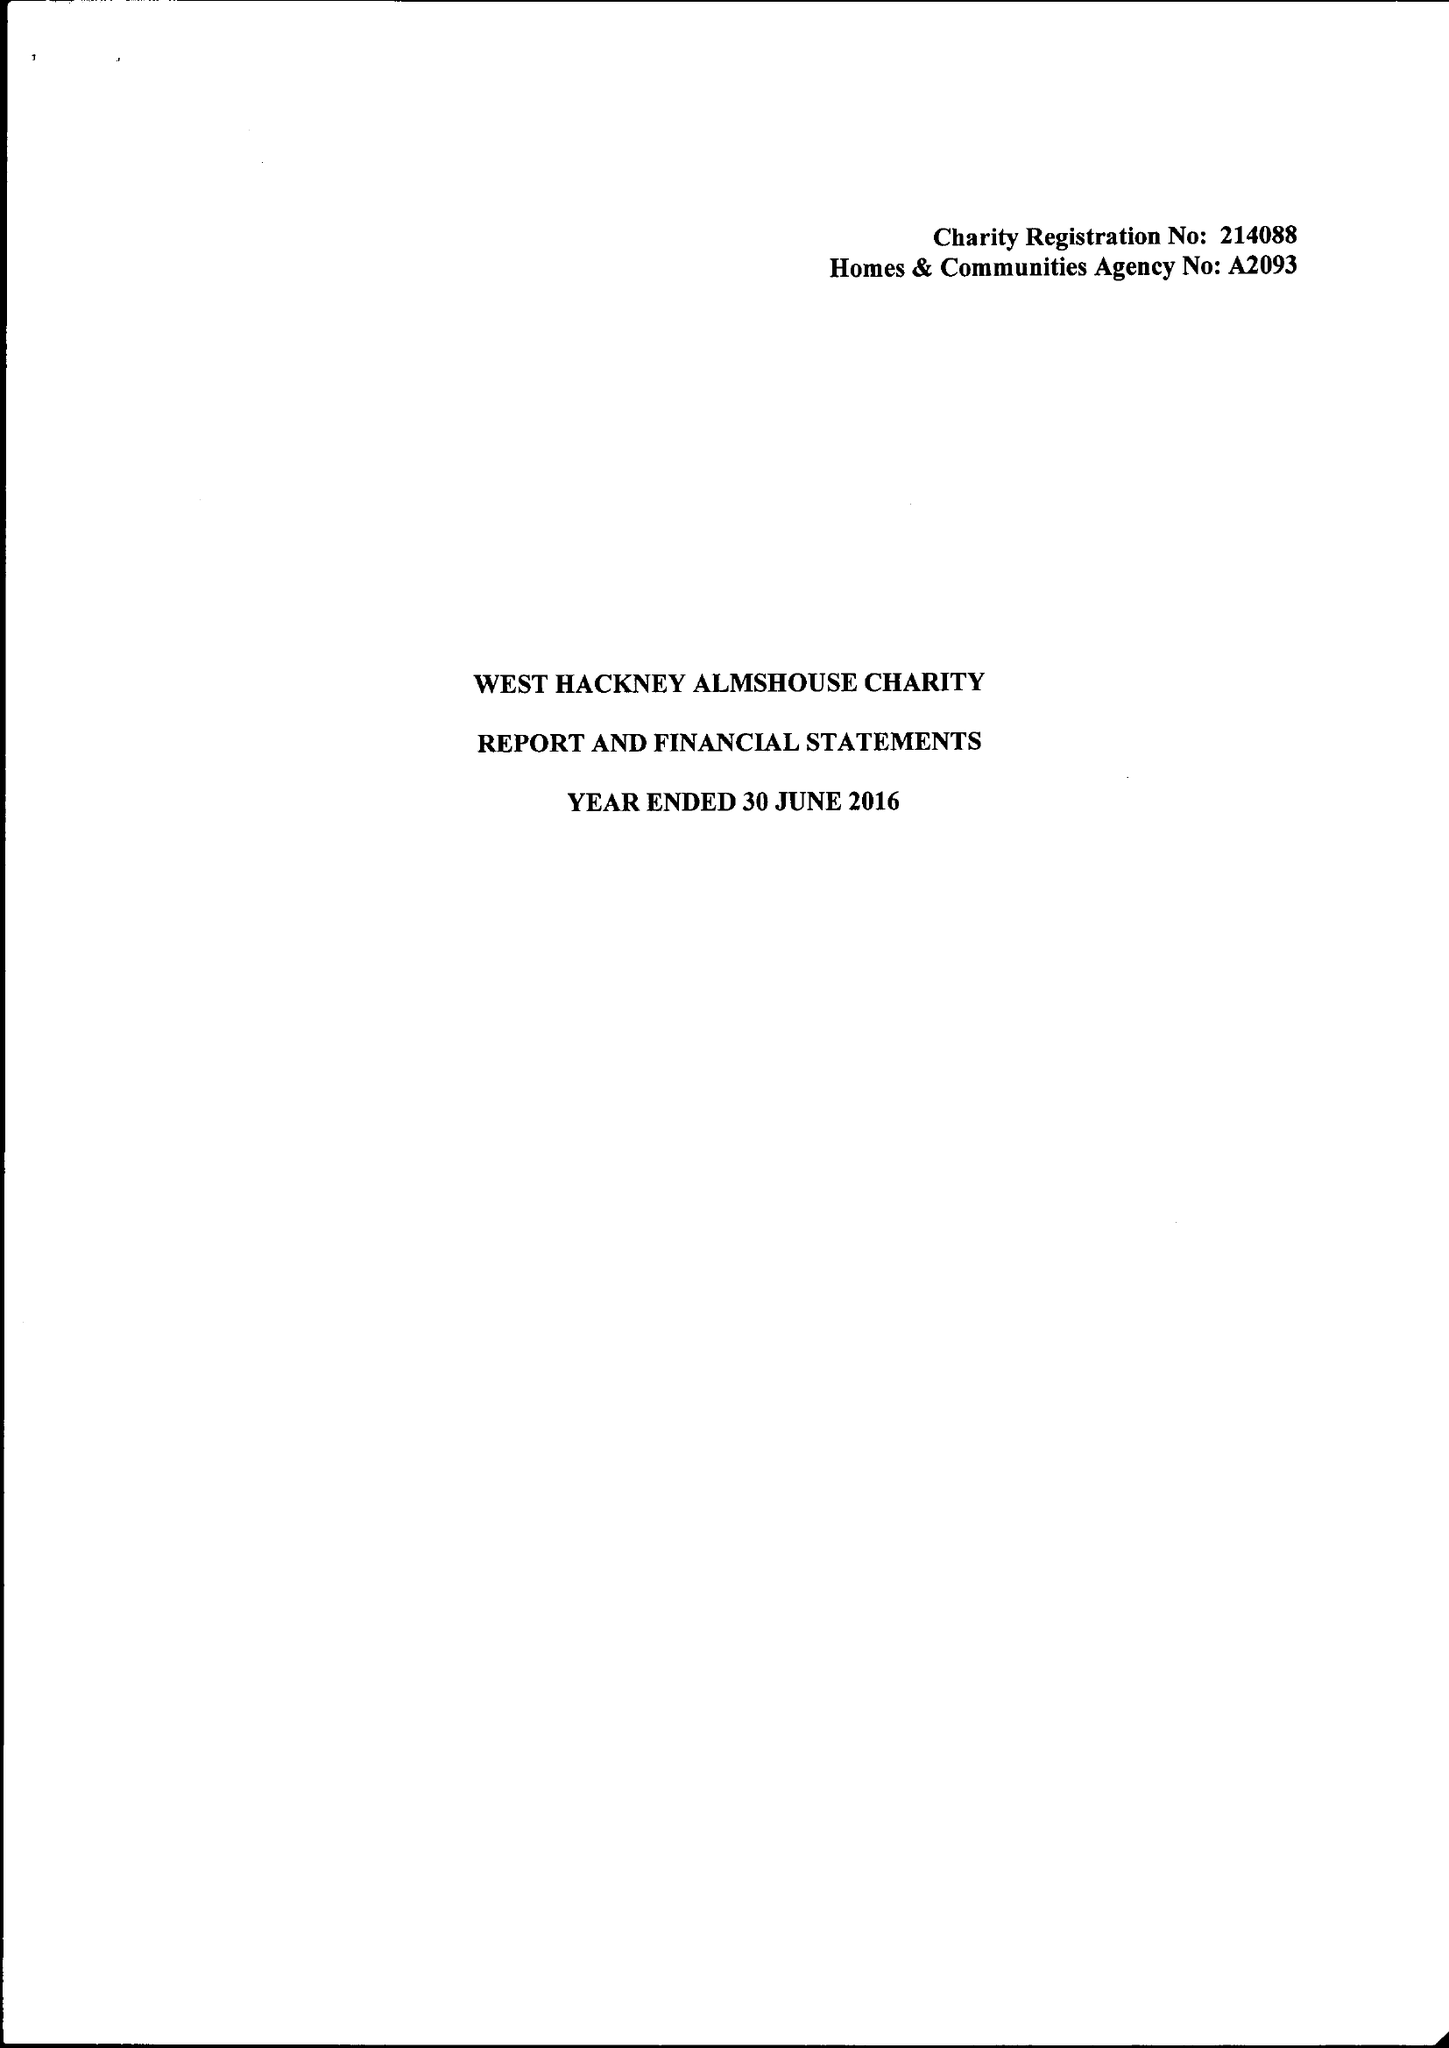What is the value for the address__post_town?
Answer the question using a single word or phrase. LONDON 